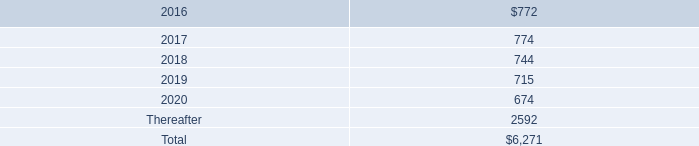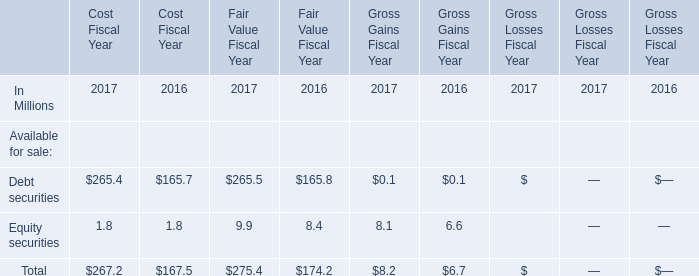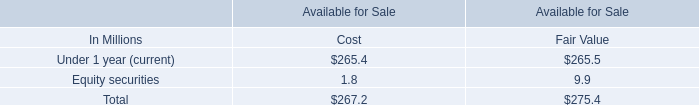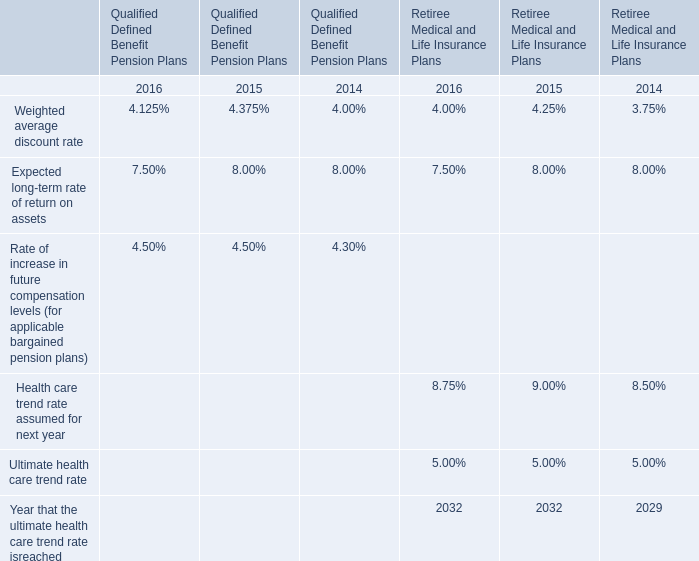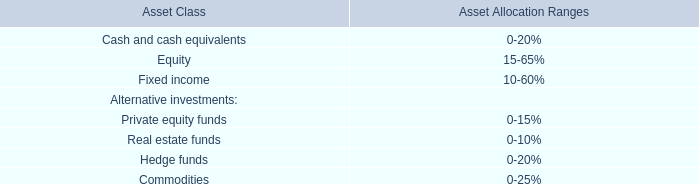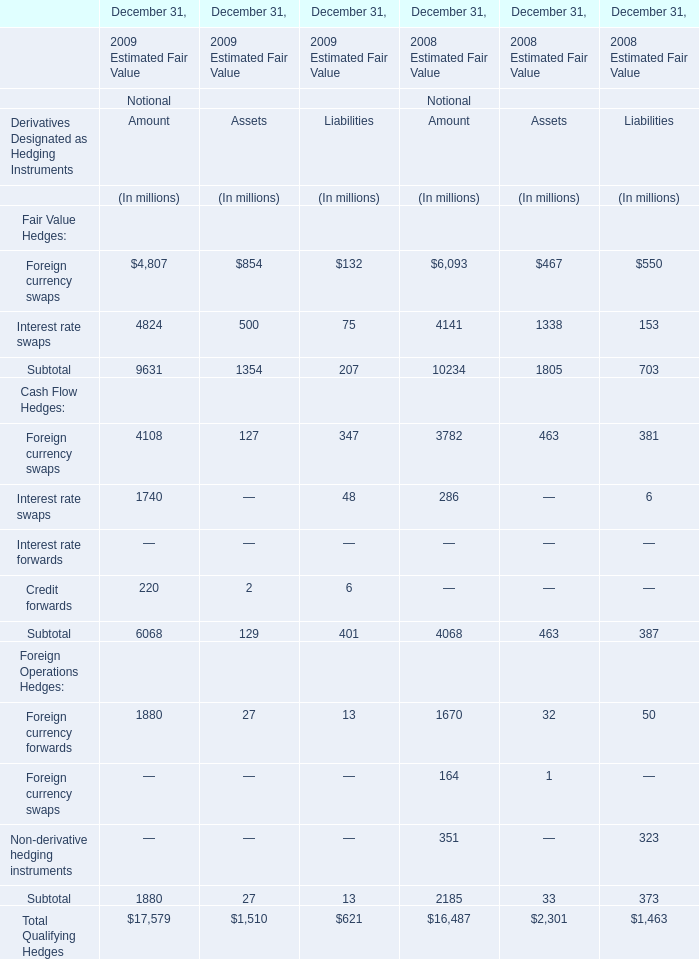what was total rent expense under all operating leases , including both cancelable and noncancelable leases , in millions , in 2015 , 2014 and 2013? 
Computations: ((794 + 717) + 645)
Answer: 2156.0. 